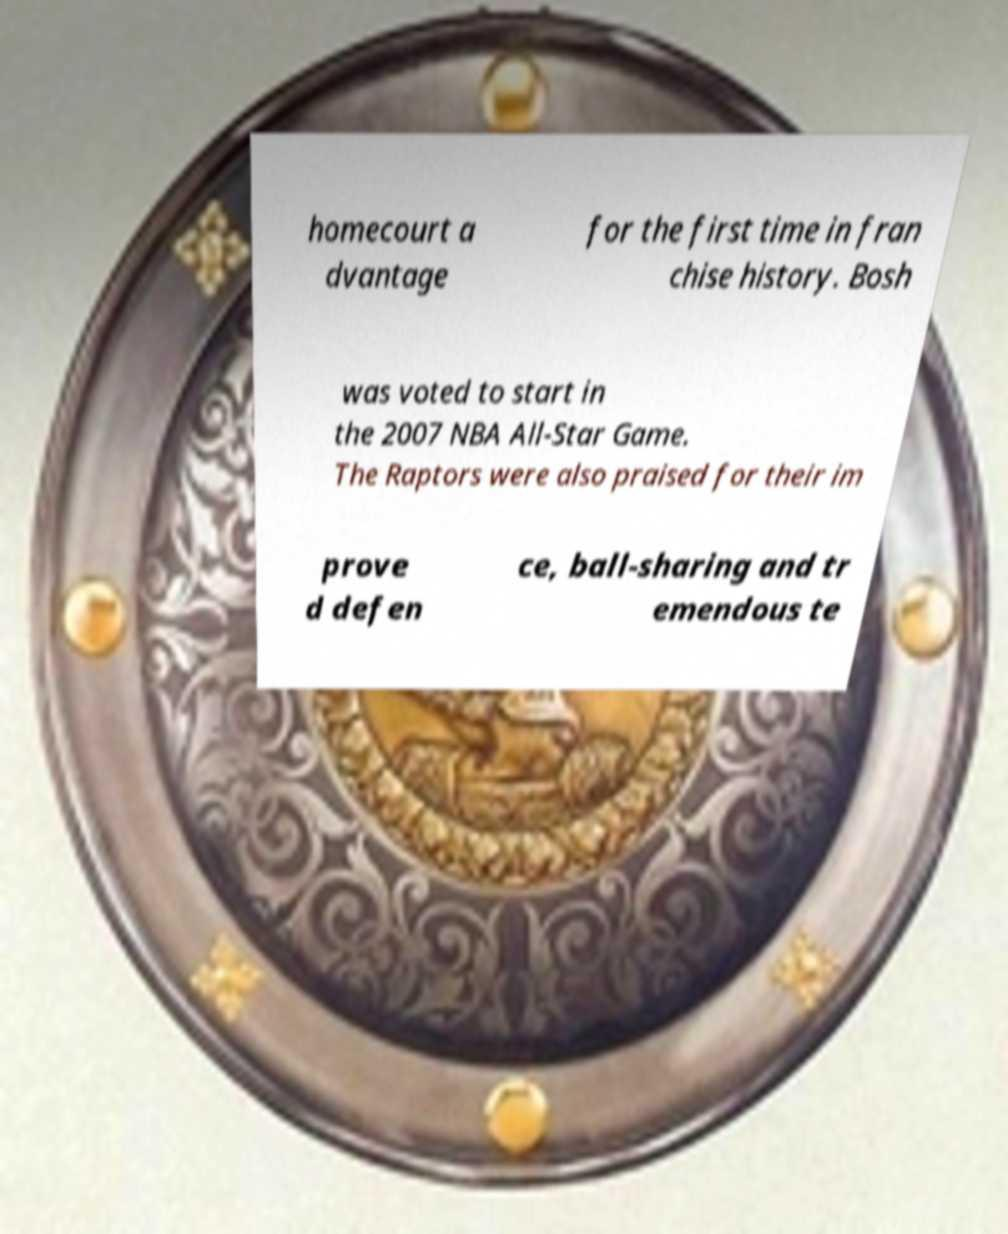Could you assist in decoding the text presented in this image and type it out clearly? homecourt a dvantage for the first time in fran chise history. Bosh was voted to start in the 2007 NBA All-Star Game. The Raptors were also praised for their im prove d defen ce, ball-sharing and tr emendous te 